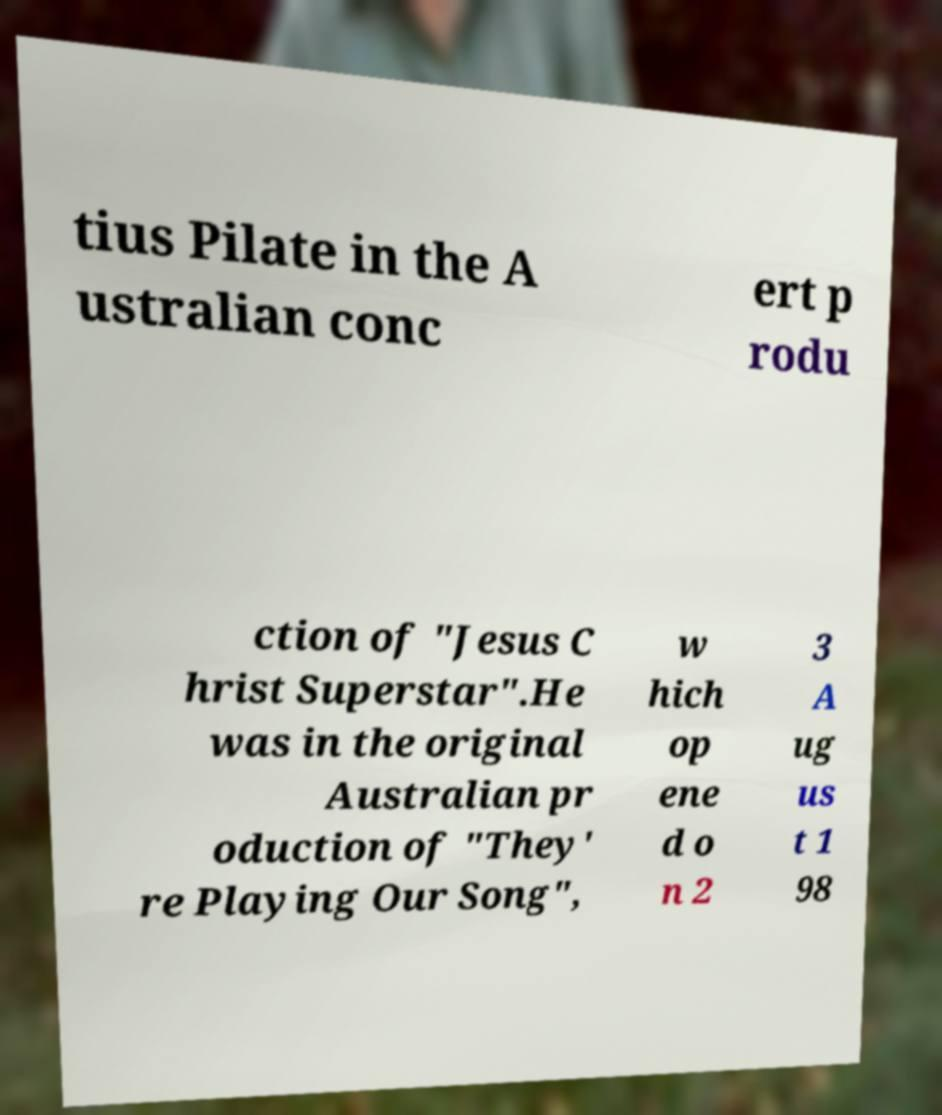Can you accurately transcribe the text from the provided image for me? tius Pilate in the A ustralian conc ert p rodu ction of "Jesus C hrist Superstar".He was in the original Australian pr oduction of "They' re Playing Our Song", w hich op ene d o n 2 3 A ug us t 1 98 